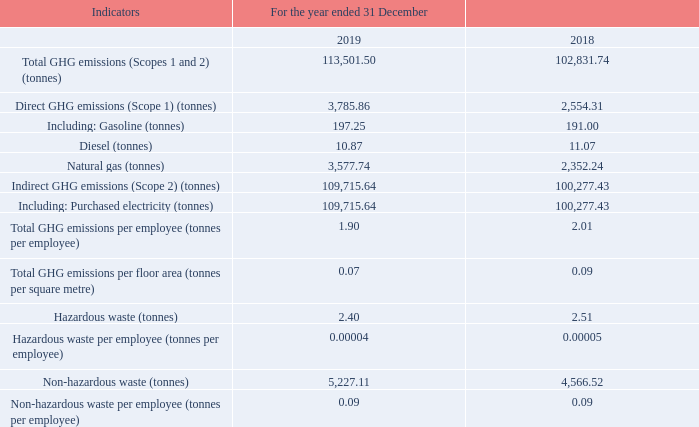Environmental Performance Summary Below are some key environmental indicators, and are compiled based on the “ESG Reporting Guide” in Appendix 27 to the Listing Rules. Unless otherwise specified, the following data covers Tencent’s major office buildings and the main data centres in Mainland China. 1. Emissions 1.1 Office Buildings
Due to its business nature, the significant air emissions of the Group are GHG emissions, arising mainly from fuels and purchased electricity produced from fossil fuels.
The Group’s GHG inventory includes carbon dioxide, methane and nitrous oxide. GHG emissions data for the year ended 31 December 2019 is presented in carbon dioxide equivalent and is calculated based on the “2017 Baseline Emission Factors for Regional Power Grids in China for CDM and CCER Projects” issued by the Ministry of Ecology and Environment of China, and the “2006 IPCC Guidelines for National Greenhouse Gas Inventories” issued by the Intergovernmental Panel on Climate Change (IPCC)
Diesel is consumed by backup power generators.
Hazardous waste produced by the Group’s office buildings mainly includes waste toner cartridge and waste ink cartridge from printing equipment. Waste toner cartridge and waste ink cartridge are centralised and disposed of by printing suppliers. Such data covers all office buildings of the Group in Mainland China.
Non-hazardous waste produced by the Group’s office buildings mainly includes domestic waste and non-hazardous office waste. Domestic waste is disposed of by the property management companies and kitchen waste recycling vendors, and its data is not available, therefore estimation of domestic waste is made with reference to “Handbook on Domestic Discharge Coefficients for Towns in the First Nationwide Census on Contaminant Discharge” published by the State Council. Non-hazardous office waste is centralised for disposal by vendors; hence such data covers all office buildings of the Group in Mainland China.
Hazardous waste produced by the Group’s data centres mainly includes waste lead-acid accumulators. Waste lead-acid accumulators are disposed of by qualified waste recycling vendors.
Non-hazardous waste produced by the Group’s data centres mainly includes waste servers and waste hard drives. Waste servers and destroyed waste hard drives are centralised and recycled by waste recycling vendors. Such data covers all the Group’s data centres.
What is diesel consumed by? Backup power generators. What does the hazardous waste produced by the Group's data centres mainly include? Waste lead-acid accumulators. What does the non-hazardous waste produced by the Group's data centres mainly include? Waste servers and waste hard drives. What is the difference between 2018 and 2019 Total GHG emissions in tonnes? 113,501.50-102,831.74
Answer: 10669.76. What is the difference between 2018 and 2019 indirect GHG emissions in tonnes? 109,715.64-100,277.43
Answer: 9438.21. What is the change between 2018 and 2019 hazardous waste(tonnes)? 2.40-2.51
Answer: -0.11. 